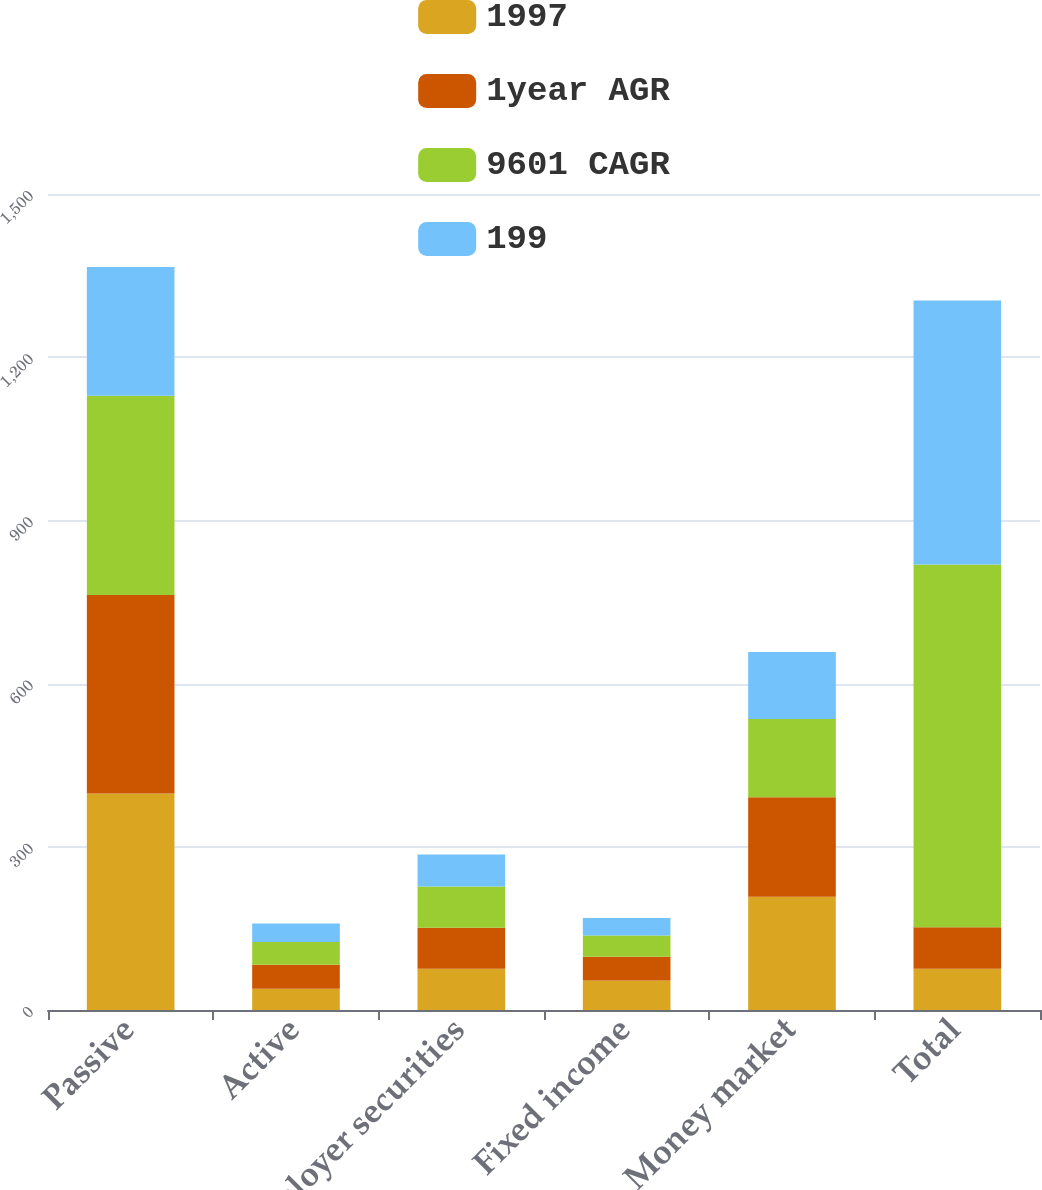Convert chart to OTSL. <chart><loc_0><loc_0><loc_500><loc_500><stacked_bar_chart><ecel><fcel>Passive<fcel>Active<fcel>Employer securities<fcel>Fixed income<fcel>Money market<fcel>Total<nl><fcel>1997<fcel>398<fcel>39<fcel>76<fcel>54<fcel>208<fcel>76<nl><fcel>1year AGR<fcel>365<fcel>44<fcel>75<fcel>44<fcel>183<fcel>76<nl><fcel>9601 CAGR<fcel>366<fcel>42<fcel>76<fcel>39<fcel>144<fcel>667<nl><fcel>199<fcel>237<fcel>34<fcel>59<fcel>32<fcel>123<fcel>485<nl></chart> 